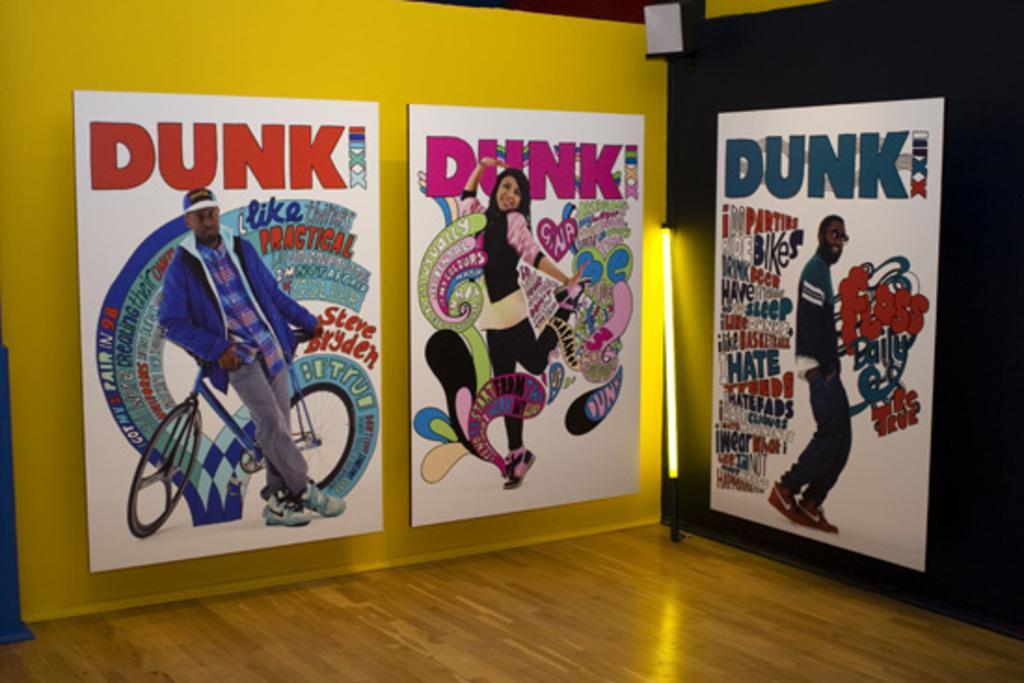Describe this image in one or two sentences. In this image we can see posters on walls. On the posters we can see people. Also something is written on the poster. On the left side poster there is a cycle. Also we can see a light. 